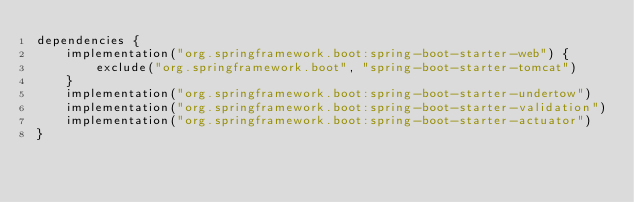<code> <loc_0><loc_0><loc_500><loc_500><_Kotlin_>dependencies {
    implementation("org.springframework.boot:spring-boot-starter-web") {
        exclude("org.springframework.boot", "spring-boot-starter-tomcat")
    }
    implementation("org.springframework.boot:spring-boot-starter-undertow")
    implementation("org.springframework.boot:spring-boot-starter-validation")
    implementation("org.springframework.boot:spring-boot-starter-actuator")
}
</code> 